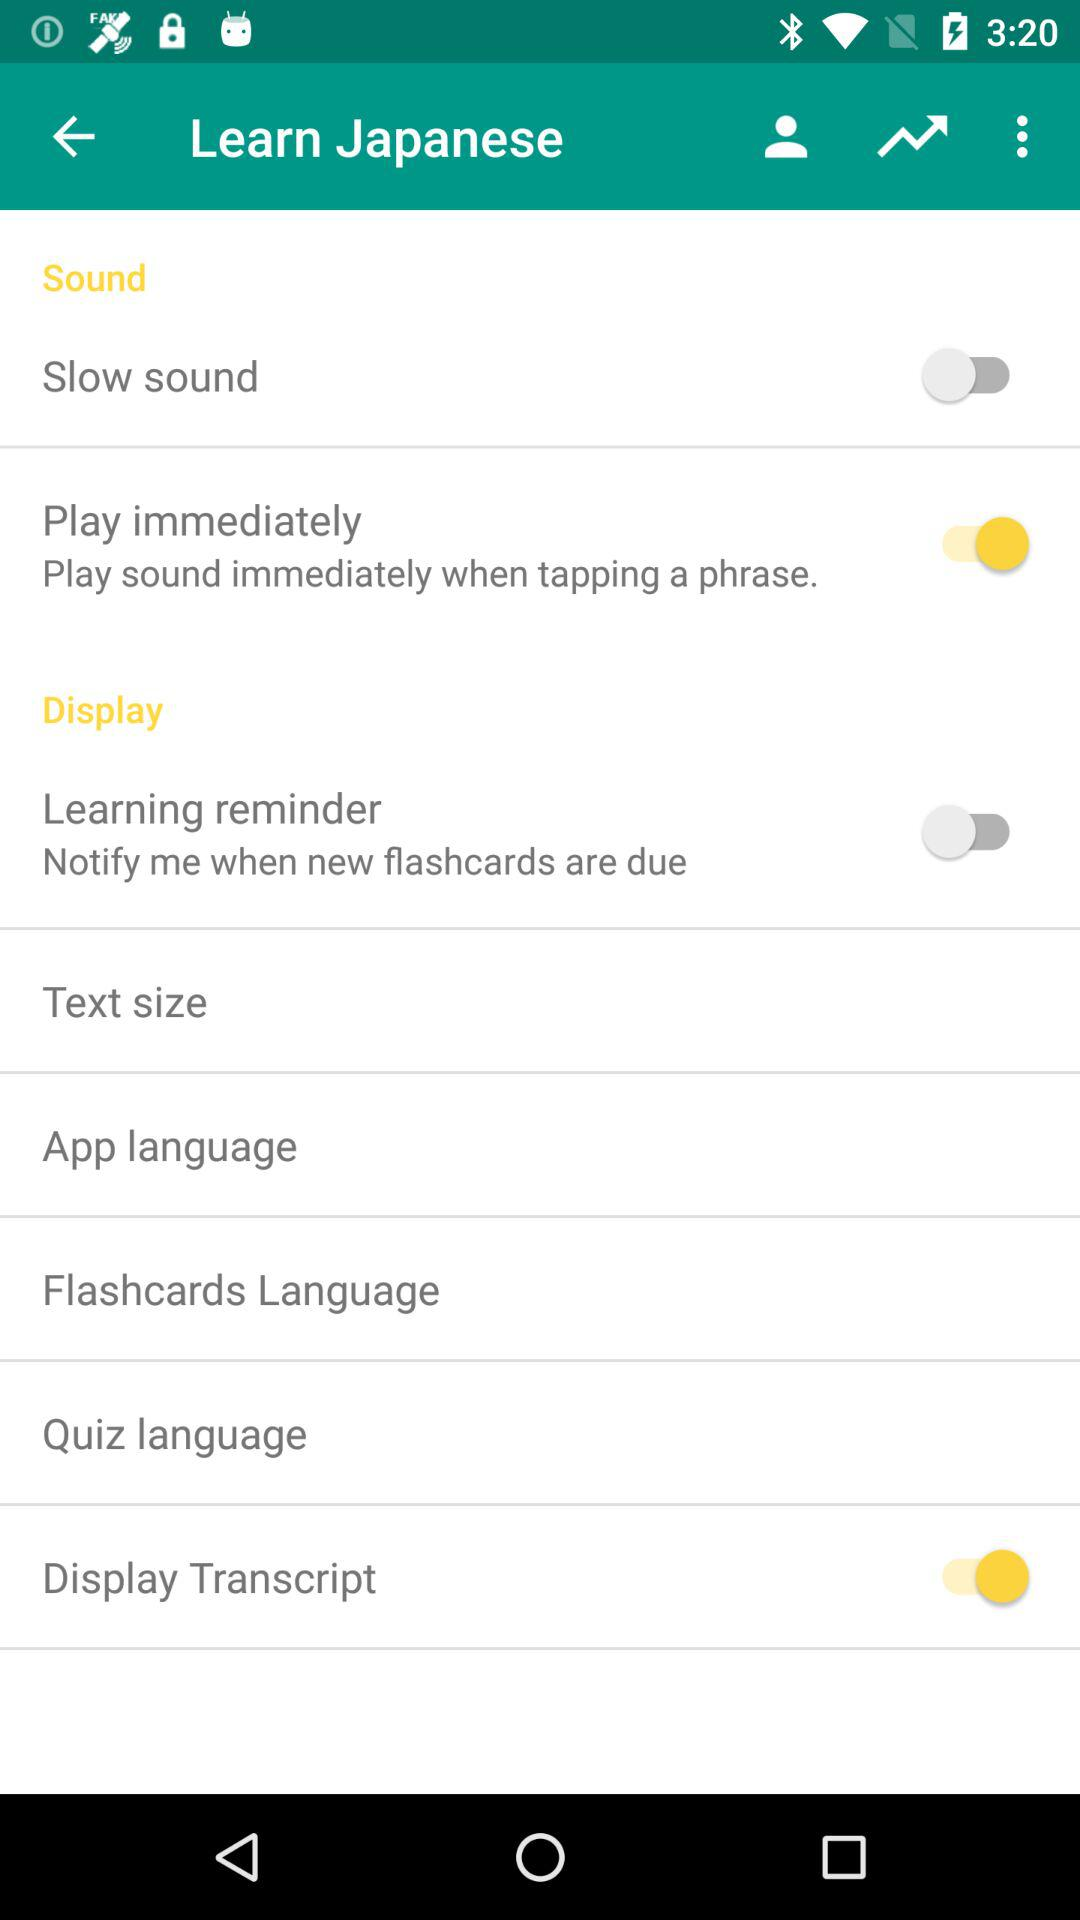What is the name of the application? The name of the application is "Learn Japanese ". 